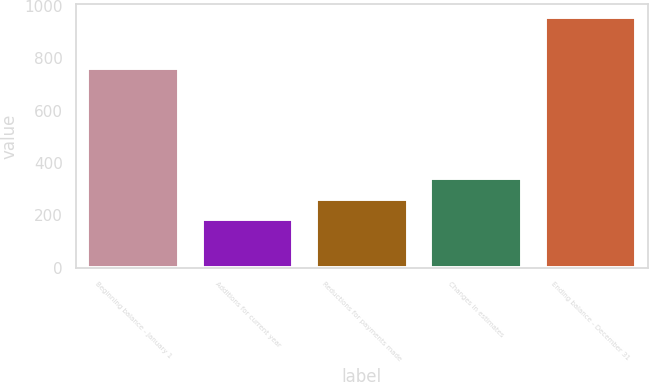Convert chart to OTSL. <chart><loc_0><loc_0><loc_500><loc_500><bar_chart><fcel>Beginning balance - January 1<fcel>Additions for current year<fcel>Reductions for payments made<fcel>Changes in estimates<fcel>Ending balance - December 31<nl><fcel>761<fcel>186<fcel>263.6<fcel>341.2<fcel>959<nl></chart> 